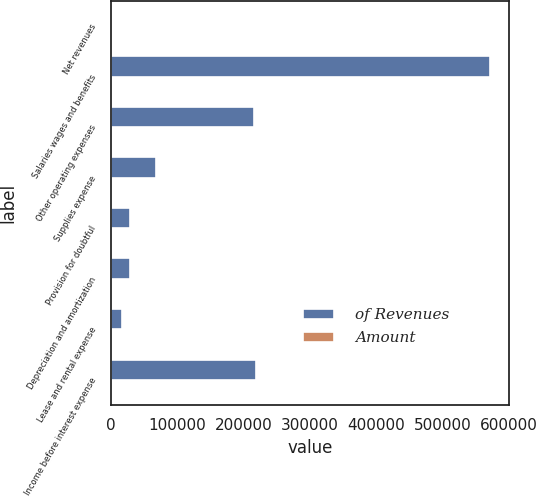<chart> <loc_0><loc_0><loc_500><loc_500><stacked_bar_chart><ecel><fcel>Net revenues<fcel>Salaries wages and benefits<fcel>Other operating expenses<fcel>Supplies expense<fcel>Provision for doubtful<fcel>Depreciation and amortization<fcel>Lease and rental expense<fcel>Income before interest expense<nl><fcel>of Revenues<fcel>100<fcel>572279<fcel>215365<fcel>67514<fcel>27907<fcel>27807<fcel>16531<fcel>218675<nl><fcel>Amount<fcel>100<fcel>49.9<fcel>18.8<fcel>5.9<fcel>2.4<fcel>2.4<fcel>1.4<fcel>19.1<nl></chart> 